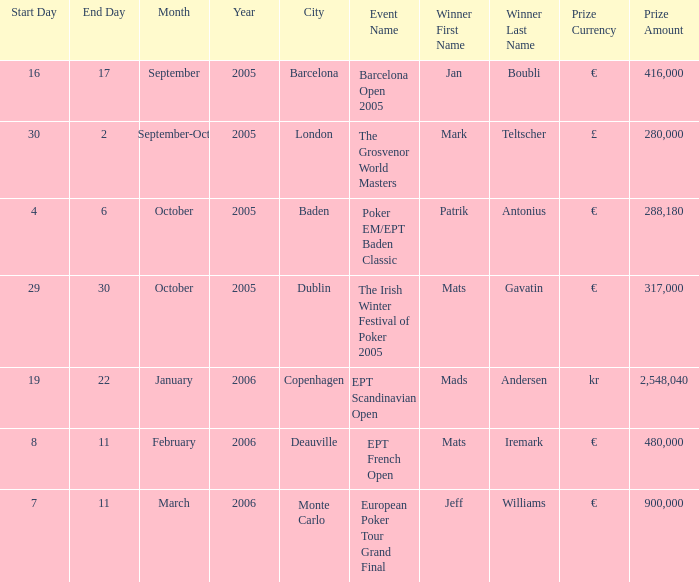When did the event take place in the city of baden? 4–6 October 2005. 